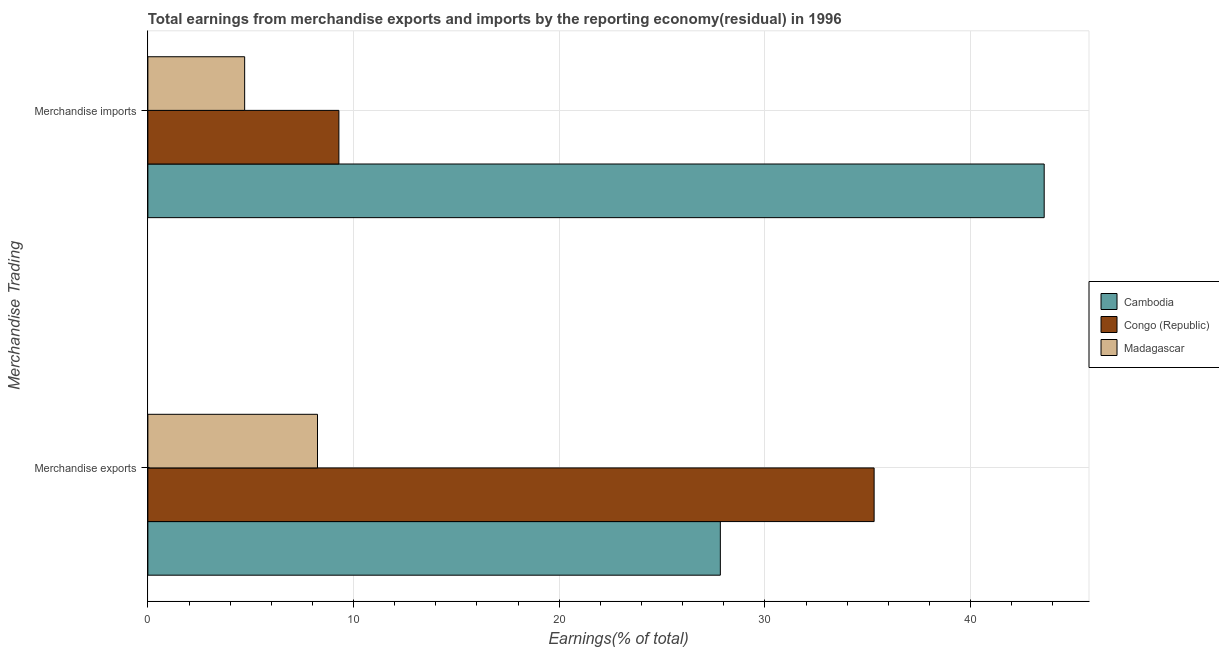How many bars are there on the 1st tick from the top?
Give a very brief answer. 3. What is the earnings from merchandise exports in Madagascar?
Keep it short and to the point. 8.25. Across all countries, what is the maximum earnings from merchandise exports?
Your answer should be very brief. 35.31. Across all countries, what is the minimum earnings from merchandise imports?
Your response must be concise. 4.71. In which country was the earnings from merchandise exports maximum?
Ensure brevity in your answer.  Congo (Republic). In which country was the earnings from merchandise imports minimum?
Give a very brief answer. Madagascar. What is the total earnings from merchandise imports in the graph?
Keep it short and to the point. 57.57. What is the difference between the earnings from merchandise exports in Cambodia and that in Madagascar?
Keep it short and to the point. 19.58. What is the difference between the earnings from merchandise exports in Cambodia and the earnings from merchandise imports in Congo (Republic)?
Ensure brevity in your answer.  18.54. What is the average earnings from merchandise imports per country?
Provide a short and direct response. 19.19. What is the difference between the earnings from merchandise imports and earnings from merchandise exports in Cambodia?
Provide a short and direct response. 15.74. What is the ratio of the earnings from merchandise imports in Madagascar to that in Cambodia?
Provide a succinct answer. 0.11. Is the earnings from merchandise imports in Congo (Republic) less than that in Madagascar?
Make the answer very short. No. In how many countries, is the earnings from merchandise imports greater than the average earnings from merchandise imports taken over all countries?
Offer a terse response. 1. What does the 1st bar from the top in Merchandise imports represents?
Offer a terse response. Madagascar. What does the 1st bar from the bottom in Merchandise imports represents?
Your response must be concise. Cambodia. How many bars are there?
Your answer should be very brief. 6. How many countries are there in the graph?
Offer a terse response. 3. What is the difference between two consecutive major ticks on the X-axis?
Keep it short and to the point. 10. Are the values on the major ticks of X-axis written in scientific E-notation?
Give a very brief answer. No. Does the graph contain any zero values?
Your answer should be very brief. No. Does the graph contain grids?
Keep it short and to the point. Yes. Where does the legend appear in the graph?
Make the answer very short. Center right. What is the title of the graph?
Make the answer very short. Total earnings from merchandise exports and imports by the reporting economy(residual) in 1996. What is the label or title of the X-axis?
Provide a succinct answer. Earnings(% of total). What is the label or title of the Y-axis?
Your answer should be very brief. Merchandise Trading. What is the Earnings(% of total) in Cambodia in Merchandise exports?
Your response must be concise. 27.83. What is the Earnings(% of total) of Congo (Republic) in Merchandise exports?
Offer a very short reply. 35.31. What is the Earnings(% of total) of Madagascar in Merchandise exports?
Give a very brief answer. 8.25. What is the Earnings(% of total) of Cambodia in Merchandise imports?
Offer a terse response. 43.57. What is the Earnings(% of total) in Congo (Republic) in Merchandise imports?
Make the answer very short. 9.29. What is the Earnings(% of total) in Madagascar in Merchandise imports?
Your response must be concise. 4.71. Across all Merchandise Trading, what is the maximum Earnings(% of total) in Cambodia?
Keep it short and to the point. 43.57. Across all Merchandise Trading, what is the maximum Earnings(% of total) in Congo (Republic)?
Your answer should be compact. 35.31. Across all Merchandise Trading, what is the maximum Earnings(% of total) of Madagascar?
Offer a very short reply. 8.25. Across all Merchandise Trading, what is the minimum Earnings(% of total) of Cambodia?
Provide a succinct answer. 27.83. Across all Merchandise Trading, what is the minimum Earnings(% of total) in Congo (Republic)?
Keep it short and to the point. 9.29. Across all Merchandise Trading, what is the minimum Earnings(% of total) of Madagascar?
Your answer should be compact. 4.71. What is the total Earnings(% of total) of Cambodia in the graph?
Your response must be concise. 71.4. What is the total Earnings(% of total) of Congo (Republic) in the graph?
Ensure brevity in your answer.  44.59. What is the total Earnings(% of total) of Madagascar in the graph?
Provide a succinct answer. 12.95. What is the difference between the Earnings(% of total) of Cambodia in Merchandise exports and that in Merchandise imports?
Offer a terse response. -15.74. What is the difference between the Earnings(% of total) in Congo (Republic) in Merchandise exports and that in Merchandise imports?
Provide a succinct answer. 26.02. What is the difference between the Earnings(% of total) of Madagascar in Merchandise exports and that in Merchandise imports?
Your answer should be very brief. 3.54. What is the difference between the Earnings(% of total) of Cambodia in Merchandise exports and the Earnings(% of total) of Congo (Republic) in Merchandise imports?
Your answer should be compact. 18.54. What is the difference between the Earnings(% of total) in Cambodia in Merchandise exports and the Earnings(% of total) in Madagascar in Merchandise imports?
Give a very brief answer. 23.12. What is the difference between the Earnings(% of total) in Congo (Republic) in Merchandise exports and the Earnings(% of total) in Madagascar in Merchandise imports?
Offer a terse response. 30.6. What is the average Earnings(% of total) in Cambodia per Merchandise Trading?
Offer a very short reply. 35.7. What is the average Earnings(% of total) of Congo (Republic) per Merchandise Trading?
Provide a short and direct response. 22.3. What is the average Earnings(% of total) in Madagascar per Merchandise Trading?
Provide a short and direct response. 6.48. What is the difference between the Earnings(% of total) of Cambodia and Earnings(% of total) of Congo (Republic) in Merchandise exports?
Ensure brevity in your answer.  -7.48. What is the difference between the Earnings(% of total) of Cambodia and Earnings(% of total) of Madagascar in Merchandise exports?
Keep it short and to the point. 19.58. What is the difference between the Earnings(% of total) in Congo (Republic) and Earnings(% of total) in Madagascar in Merchandise exports?
Your answer should be very brief. 27.06. What is the difference between the Earnings(% of total) in Cambodia and Earnings(% of total) in Congo (Republic) in Merchandise imports?
Keep it short and to the point. 34.29. What is the difference between the Earnings(% of total) in Cambodia and Earnings(% of total) in Madagascar in Merchandise imports?
Provide a succinct answer. 38.87. What is the difference between the Earnings(% of total) of Congo (Republic) and Earnings(% of total) of Madagascar in Merchandise imports?
Offer a terse response. 4.58. What is the ratio of the Earnings(% of total) of Cambodia in Merchandise exports to that in Merchandise imports?
Keep it short and to the point. 0.64. What is the ratio of the Earnings(% of total) of Congo (Republic) in Merchandise exports to that in Merchandise imports?
Ensure brevity in your answer.  3.8. What is the ratio of the Earnings(% of total) in Madagascar in Merchandise exports to that in Merchandise imports?
Provide a succinct answer. 1.75. What is the difference between the highest and the second highest Earnings(% of total) of Cambodia?
Give a very brief answer. 15.74. What is the difference between the highest and the second highest Earnings(% of total) in Congo (Republic)?
Offer a terse response. 26.02. What is the difference between the highest and the second highest Earnings(% of total) in Madagascar?
Ensure brevity in your answer.  3.54. What is the difference between the highest and the lowest Earnings(% of total) of Cambodia?
Offer a very short reply. 15.74. What is the difference between the highest and the lowest Earnings(% of total) of Congo (Republic)?
Keep it short and to the point. 26.02. What is the difference between the highest and the lowest Earnings(% of total) in Madagascar?
Offer a terse response. 3.54. 